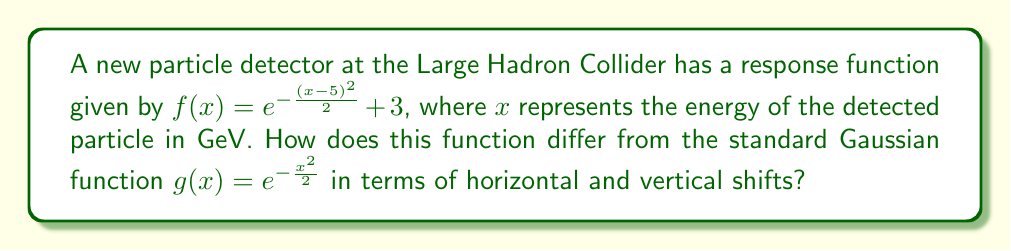What is the answer to this math problem? To determine the horizontal and vertical shifts, we'll compare the given function $f(x)$ to the standard Gaussian function $g(x)$:

1. Horizontal shift:
   - In $f(x)$, we see $(x-5)^2$ instead of $x^2$.
   - This indicates a horizontal shift of 5 units to the right.
   - The general form for a horizontal shift is $f(x-h)$, where $h$ is the shift to the right.

2. Vertical shift:
   - In $f(x)$, we see $+3$ added at the end of the function.
   - This indicates a vertical shift of 3 units upward.
   - The general form for a vertical shift is $f(x) + k$, where $k$ is the shift upward.

3. Combining the shifts:
   - The function $f(x) = e^{-\frac{(x-5)^2}{2}} + 3$ can be seen as a transformation of $g(x) = e^{-\frac{x^2}{2}}$.
   - It's shifted 5 units right and 3 units up.

Therefore, compared to the standard Gaussian function, the detector response function is shifted 5 units right (horizontal shift) and 3 units up (vertical shift).
Answer: Horizontal shift: 5 units right; Vertical shift: 3 units up 